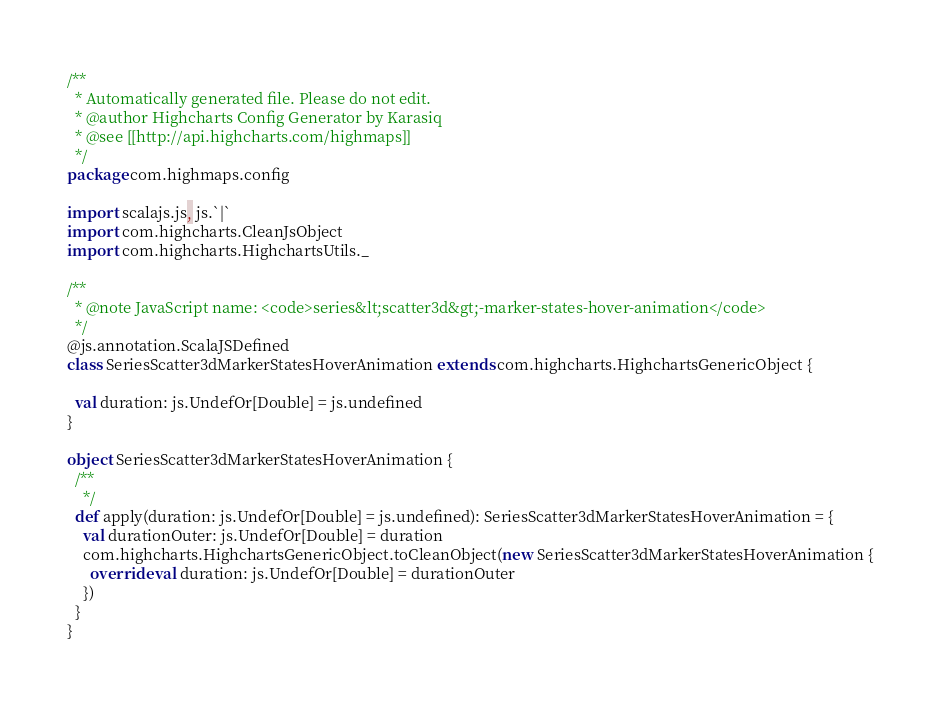Convert code to text. <code><loc_0><loc_0><loc_500><loc_500><_Scala_>/**
  * Automatically generated file. Please do not edit.
  * @author Highcharts Config Generator by Karasiq
  * @see [[http://api.highcharts.com/highmaps]]
  */
package com.highmaps.config

import scalajs.js, js.`|`
import com.highcharts.CleanJsObject
import com.highcharts.HighchartsUtils._

/**
  * @note JavaScript name: <code>series&lt;scatter3d&gt;-marker-states-hover-animation</code>
  */
@js.annotation.ScalaJSDefined
class SeriesScatter3dMarkerStatesHoverAnimation extends com.highcharts.HighchartsGenericObject {

  val duration: js.UndefOr[Double] = js.undefined
}

object SeriesScatter3dMarkerStatesHoverAnimation {
  /**
    */
  def apply(duration: js.UndefOr[Double] = js.undefined): SeriesScatter3dMarkerStatesHoverAnimation = {
    val durationOuter: js.UndefOr[Double] = duration
    com.highcharts.HighchartsGenericObject.toCleanObject(new SeriesScatter3dMarkerStatesHoverAnimation {
      override val duration: js.UndefOr[Double] = durationOuter
    })
  }
}
</code> 